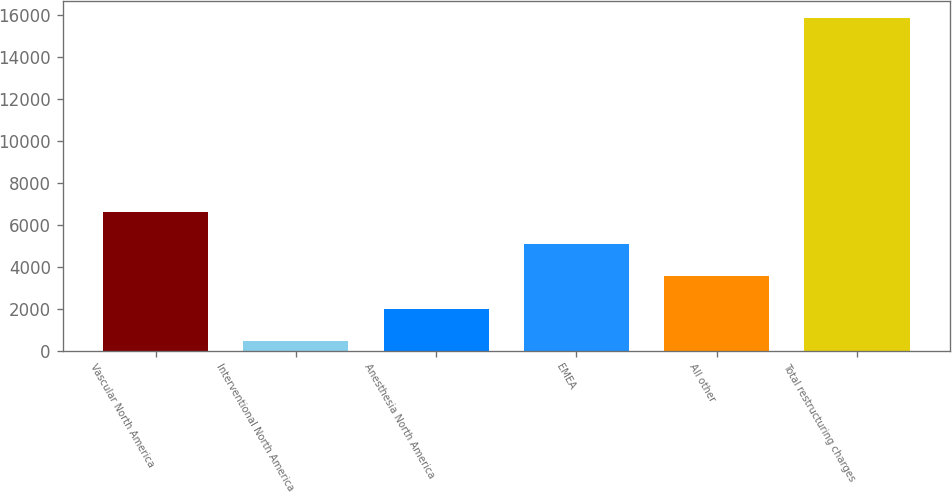Convert chart to OTSL. <chart><loc_0><loc_0><loc_500><loc_500><bar_chart><fcel>Vascular North America<fcel>Interventional North America<fcel>Anesthesia North America<fcel>EMEA<fcel>All other<fcel>Total restructuring charges<nl><fcel>6623.8<fcel>459<fcel>2000.2<fcel>5082.6<fcel>3541.4<fcel>15871<nl></chart> 